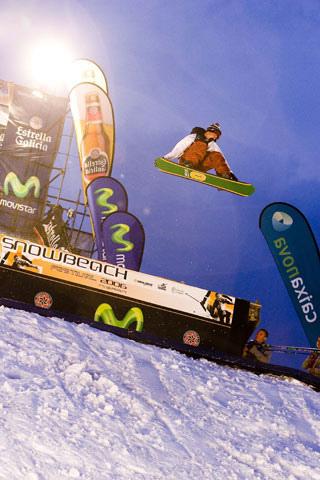Is this happening during the day?
Keep it brief. Yes. What sport is this?
Quick response, please. Snowboarding. Is there anyone on these equipment?
Keep it brief. Yes. 